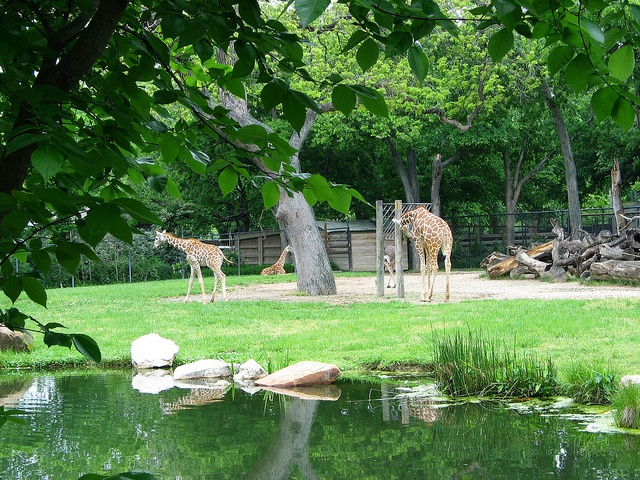Describe the objects in this image and their specific colors. I can see giraffe in black, ivory, tan, and darkgray tones, giraffe in black, ivory, beige, darkgray, and tan tones, and giraffe in black, tan, and darkgray tones in this image. 